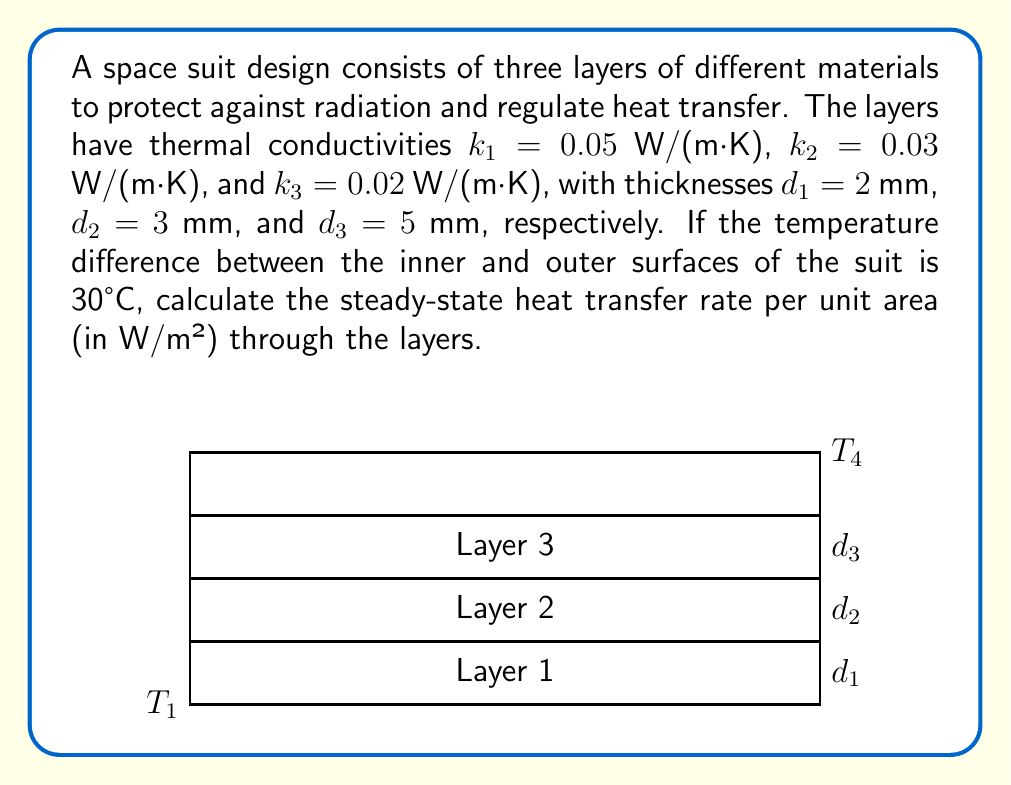Provide a solution to this math problem. To solve this problem, we'll use the concept of thermal resistance in series and Fourier's law of heat conduction. The steps are as follows:

1) The thermal resistance for each layer is given by:
   $$R_i = \frac{d_i}{k_i}$$

2) Calculate the thermal resistance for each layer:
   $$R_1 = \frac{0.002}{0.05} = 0.04 \text{ m²K/W}$$
   $$R_2 = \frac{0.003}{0.03} = 0.10 \text{ m²K/W}$$
   $$R_3 = \frac{0.005}{0.02} = 0.25 \text{ m²K/W}$$

3) The total thermal resistance is the sum of individual resistances:
   $$R_{\text{total}} = R_1 + R_2 + R_3 = 0.04 + 0.10 + 0.25 = 0.39 \text{ m²K/W}$$

4) The heat transfer rate per unit area (q) is given by:
   $$q = \frac{\Delta T}{R_{\text{total}}}$$

   where $\Delta T$ is the temperature difference across the entire suit.

5) Substituting the values:
   $$q = \frac{30}{0.39} = 76.92 \text{ W/m²}$$

Therefore, the steady-state heat transfer rate per unit area through the space suit layers is approximately 76.92 W/m².
Answer: 76.92 W/m² 